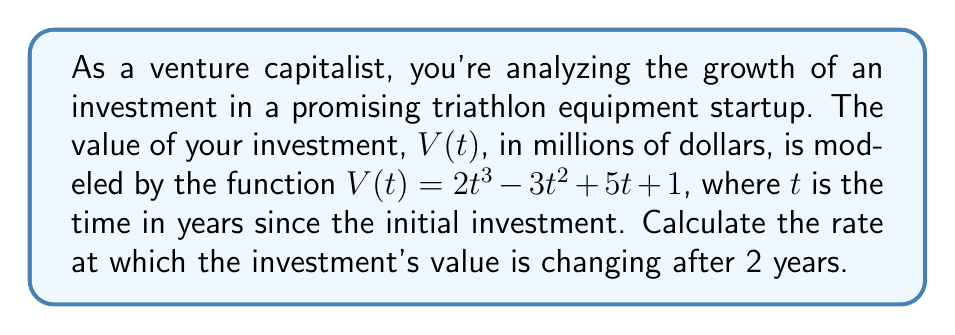Help me with this question. To find the rate of change in the investment's value after 2 years, we need to:

1. Find the derivative of the function $V(t)$, which represents the rate of change.
2. Evaluate the derivative at $t = 2$.

Step 1: Find the derivative of $V(t)$

Using the power rule and constant rule of differentiation:

$$\frac{d}{dt}[V(t)] = V'(t) = \frac{d}{dt}[2t^3 - 3t^2 + 5t + 1]$$
$$V'(t) = 6t^2 - 6t + 5$$

This function $V'(t)$ represents the instantaneous rate of change of the investment's value at any time $t$.

Step 2: Evaluate $V'(t)$ at $t = 2$

$$V'(2) = 6(2)^2 - 6(2) + 5$$
$$= 6(4) - 12 + 5$$
$$= 24 - 12 + 5$$
$$= 17$$

Therefore, after 2 years, the investment's value is changing at a rate of 17 million dollars per year.
Answer: $17$ million dollars per year 